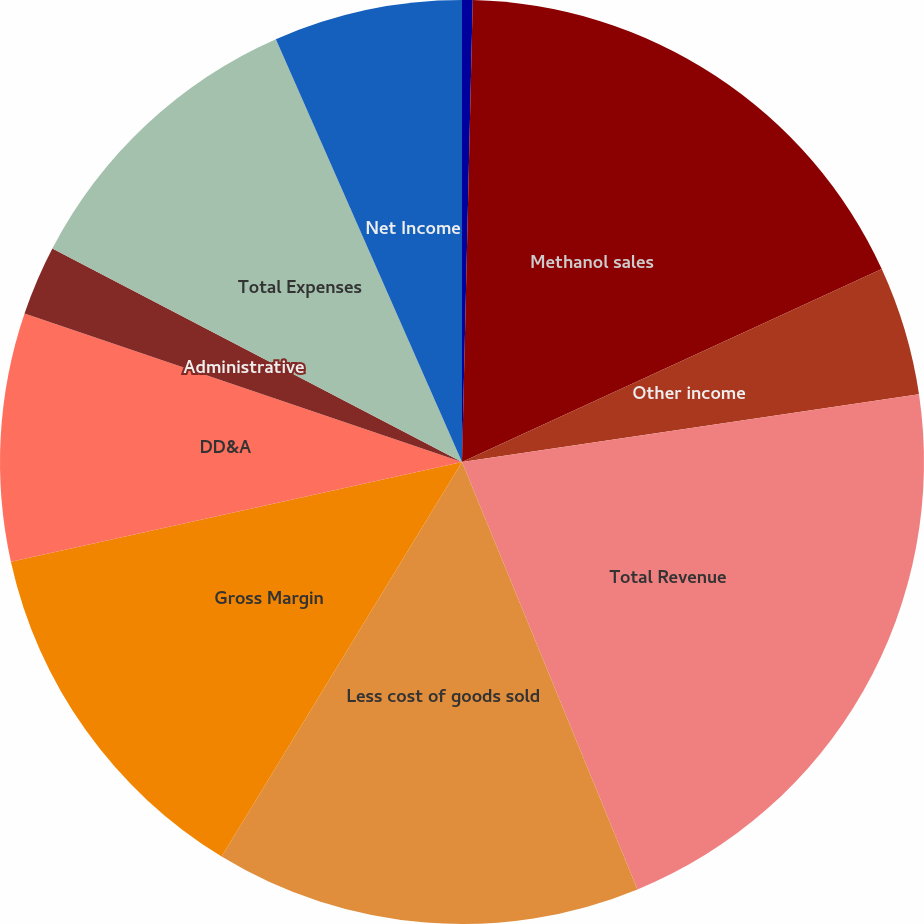Convert chart. <chart><loc_0><loc_0><loc_500><loc_500><pie_chart><fcel>(in thousands)<fcel>Methanol sales<fcel>Other income<fcel>Total Revenue<fcel>Less cost of goods sold<fcel>Gross Margin<fcel>DD&A<fcel>Administrative<fcel>Total Expenses<fcel>Net Income<nl><fcel>0.37%<fcel>17.77%<fcel>4.52%<fcel>21.14%<fcel>14.91%<fcel>12.83%<fcel>8.67%<fcel>2.44%<fcel>10.75%<fcel>6.6%<nl></chart> 